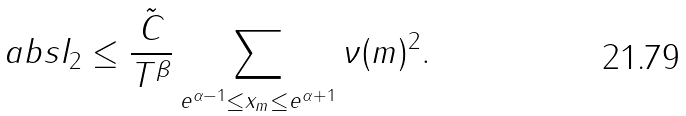Convert formula to latex. <formula><loc_0><loc_0><loc_500><loc_500>\ a b s { I _ { 2 } } \leq \frac { \tilde { C } } { T ^ { \beta } } \sum _ { e ^ { \alpha - 1 } \leq x _ { m } \leq e ^ { \alpha + 1 } } \nu ( m ) ^ { 2 } .</formula> 